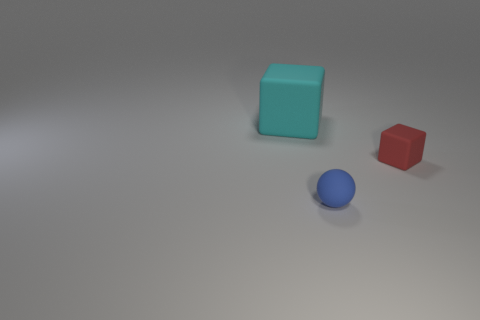Is there a big thing of the same color as the small cube?
Make the answer very short. No. There is a tiny matte object behind the blue rubber ball; is its shape the same as the object that is behind the red rubber cube?
Your answer should be compact. Yes. Is there another small red block made of the same material as the tiny red block?
Provide a short and direct response. No. What number of blue objects are tiny cubes or tiny matte things?
Ensure brevity in your answer.  1. There is a matte object that is in front of the big cyan matte thing and on the left side of the red cube; what size is it?
Ensure brevity in your answer.  Small. Is the number of small rubber objects right of the blue thing greater than the number of large blue matte balls?
Keep it short and to the point. Yes. How many balls are small blue things or rubber objects?
Keep it short and to the point. 1. There is a object that is right of the cyan rubber thing and behind the small blue matte ball; what is its shape?
Make the answer very short. Cube. Are there the same number of rubber balls that are behind the small cube and large objects that are in front of the cyan cube?
Provide a succinct answer. Yes. What number of objects are either tiny matte spheres or large green matte objects?
Your answer should be compact. 1. 